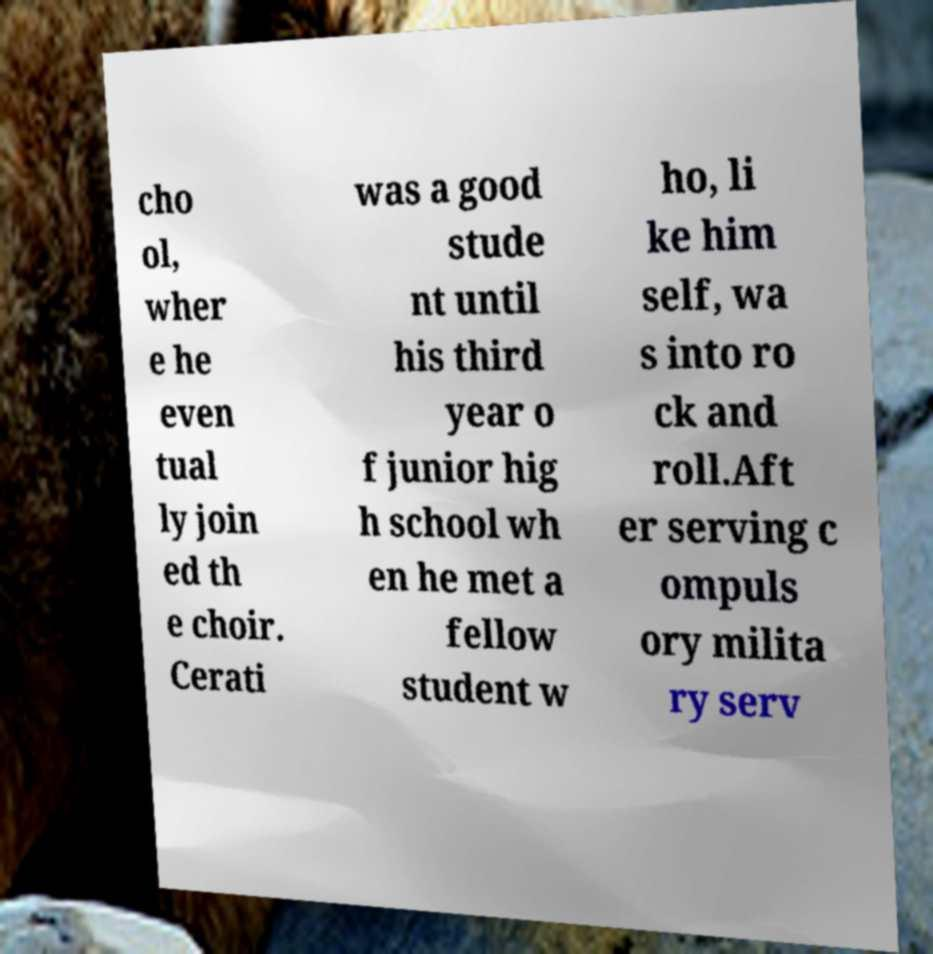Could you assist in decoding the text presented in this image and type it out clearly? cho ol, wher e he even tual ly join ed th e choir. Cerati was a good stude nt until his third year o f junior hig h school wh en he met a fellow student w ho, li ke him self, wa s into ro ck and roll.Aft er serving c ompuls ory milita ry serv 